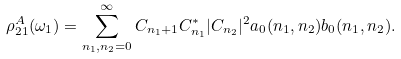<formula> <loc_0><loc_0><loc_500><loc_500>\rho ^ { A } _ { 2 1 } ( \omega _ { 1 } ) = \sum ^ { \infty } _ { n _ { 1 } , n _ { 2 } = 0 } C _ { n _ { 1 } + 1 } C ^ { * } _ { n _ { 1 } } | C _ { n _ { 2 } } | ^ { 2 } a _ { 0 } ( n _ { 1 } , n _ { 2 } ) b _ { 0 } ( n _ { 1 } , n _ { 2 } ) .</formula> 